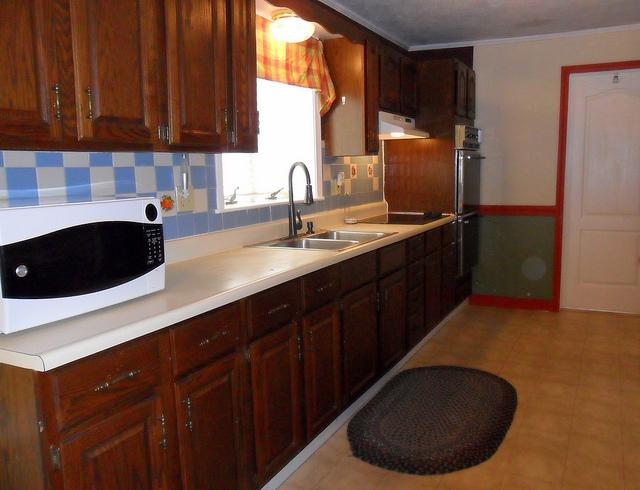What is the name for the pattern used on the window curtains? Please explain your reasoning. plaid. The name is plaid. 